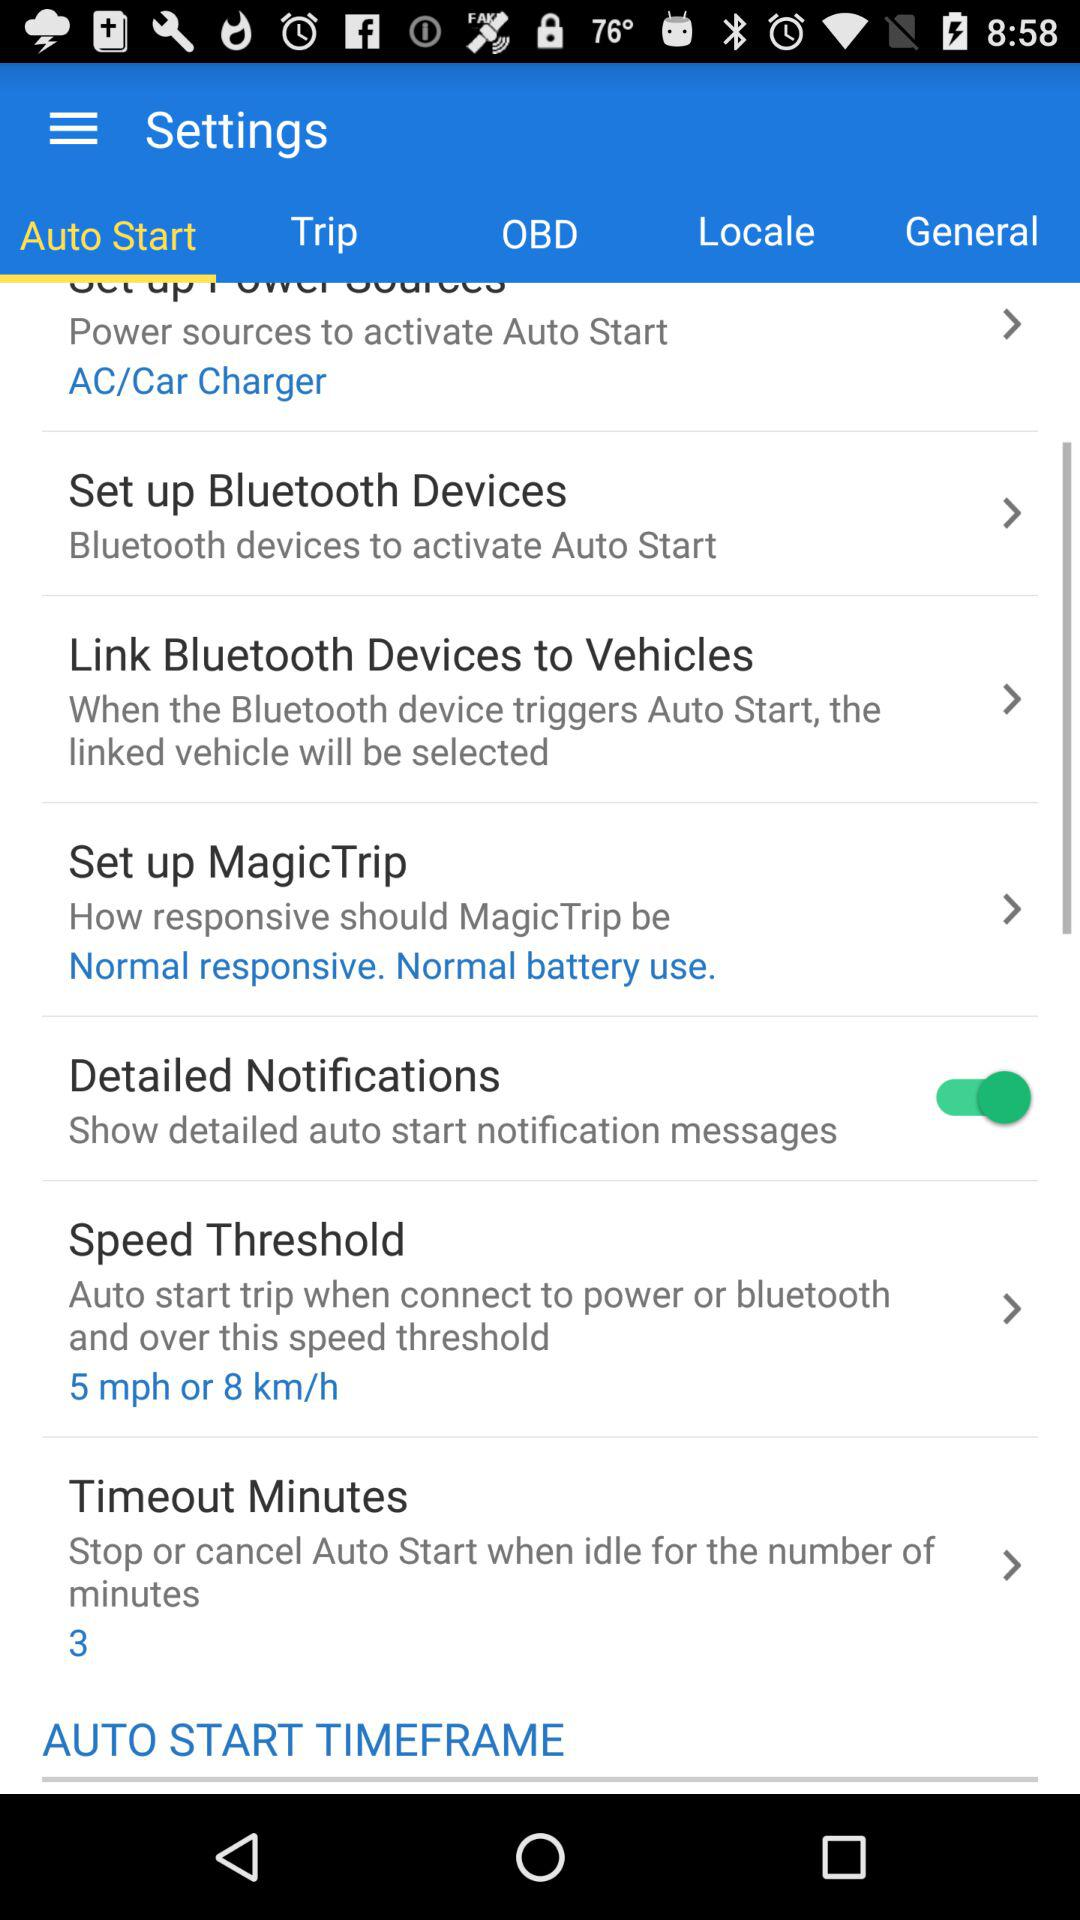After 3 minutes, what will happen in the timeout minutes? After 3 minutes, it will stop or cancel Auto Start when idle for the number of minutes. 